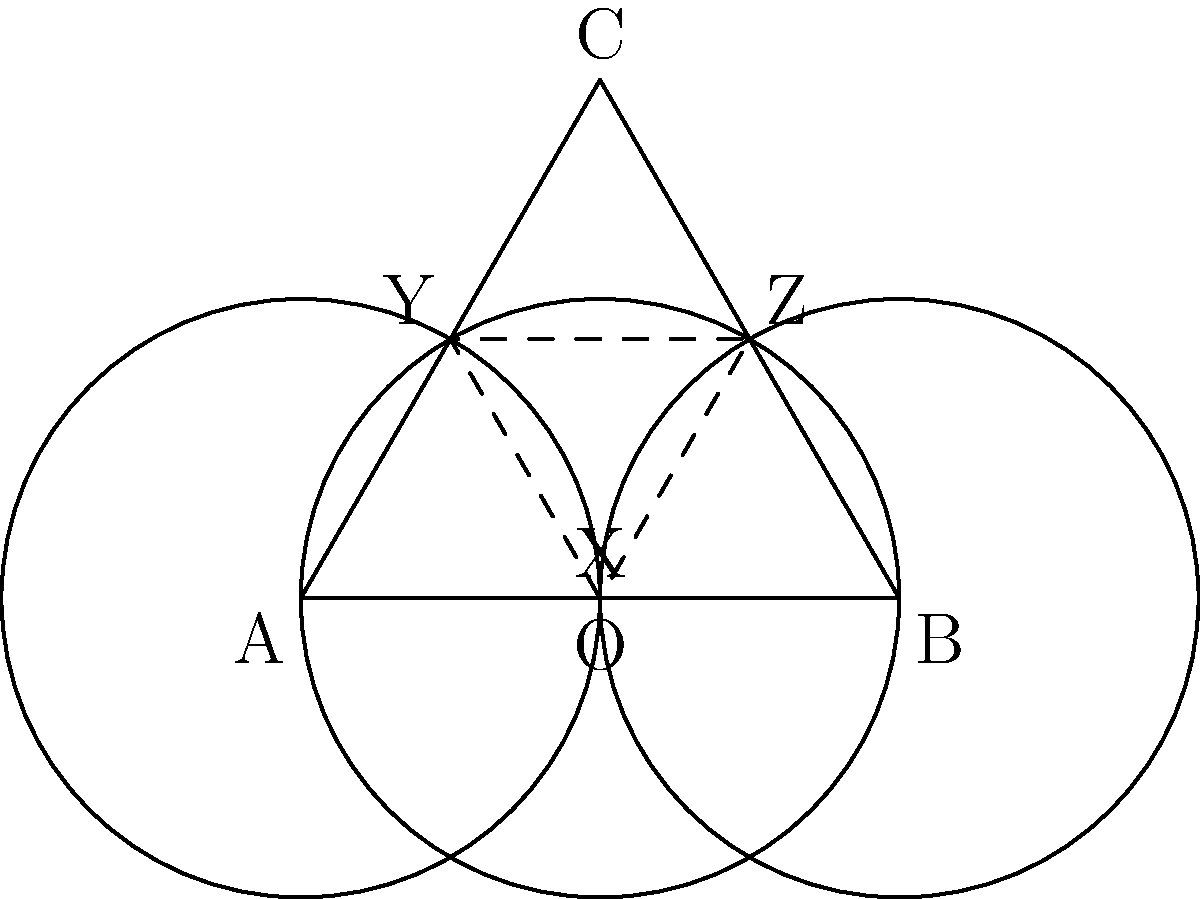In designing a unique sleeve pattern inspired by film reels, you've created three overlapping circles. If the centers of these circles form an equilateral triangle ABC with side length 2 units, what is the area of the central region XYZ formed by the intersections of all three circles? Let's approach this step-by-step:

1) First, we need to recognize that the central region XYZ is a curvilinear triangle formed by the intersections of three unit circles.

2) The centers of these circles form an equilateral triangle ABC with side length 2.

3) The area of this curvilinear triangle can be calculated using the formula:

   $$\text{Area} = 3(\text{Area of circular sector} - \text{Area of isosceles triangle})$$

4) The central angle of each circular sector is 60°, or $\frac{\pi}{3}$ radians.

5) Area of each circular sector:
   $$\text{Area}_{\text{sector}} = \frac{1}{2} r^2 \theta = \frac{1}{2} \cdot 1^2 \cdot \frac{\pi}{3} = \frac{\pi}{6}$$

6) The isosceles triangle has a base of 1 (radius) and height of $\frac{\sqrt{3}}{2}$ (half the height of the equilateral triangle).
   
   $$\text{Area}_{\text{triangle}} = \frac{1}{2} \cdot 1 \cdot \frac{\sqrt{3}}{2} = \frac{\sqrt{3}}{4}$$

7) Therefore, the area of the curvilinear triangle is:

   $$\text{Area}_{\text{XYZ}} = 3\left(\frac{\pi}{6} - \frac{\sqrt{3}}{4}\right) = \frac{\pi}{2} - \frac{3\sqrt{3}}{4}$$
Answer: $\frac{\pi}{2} - \frac{3\sqrt{3}}{4}$ square units 